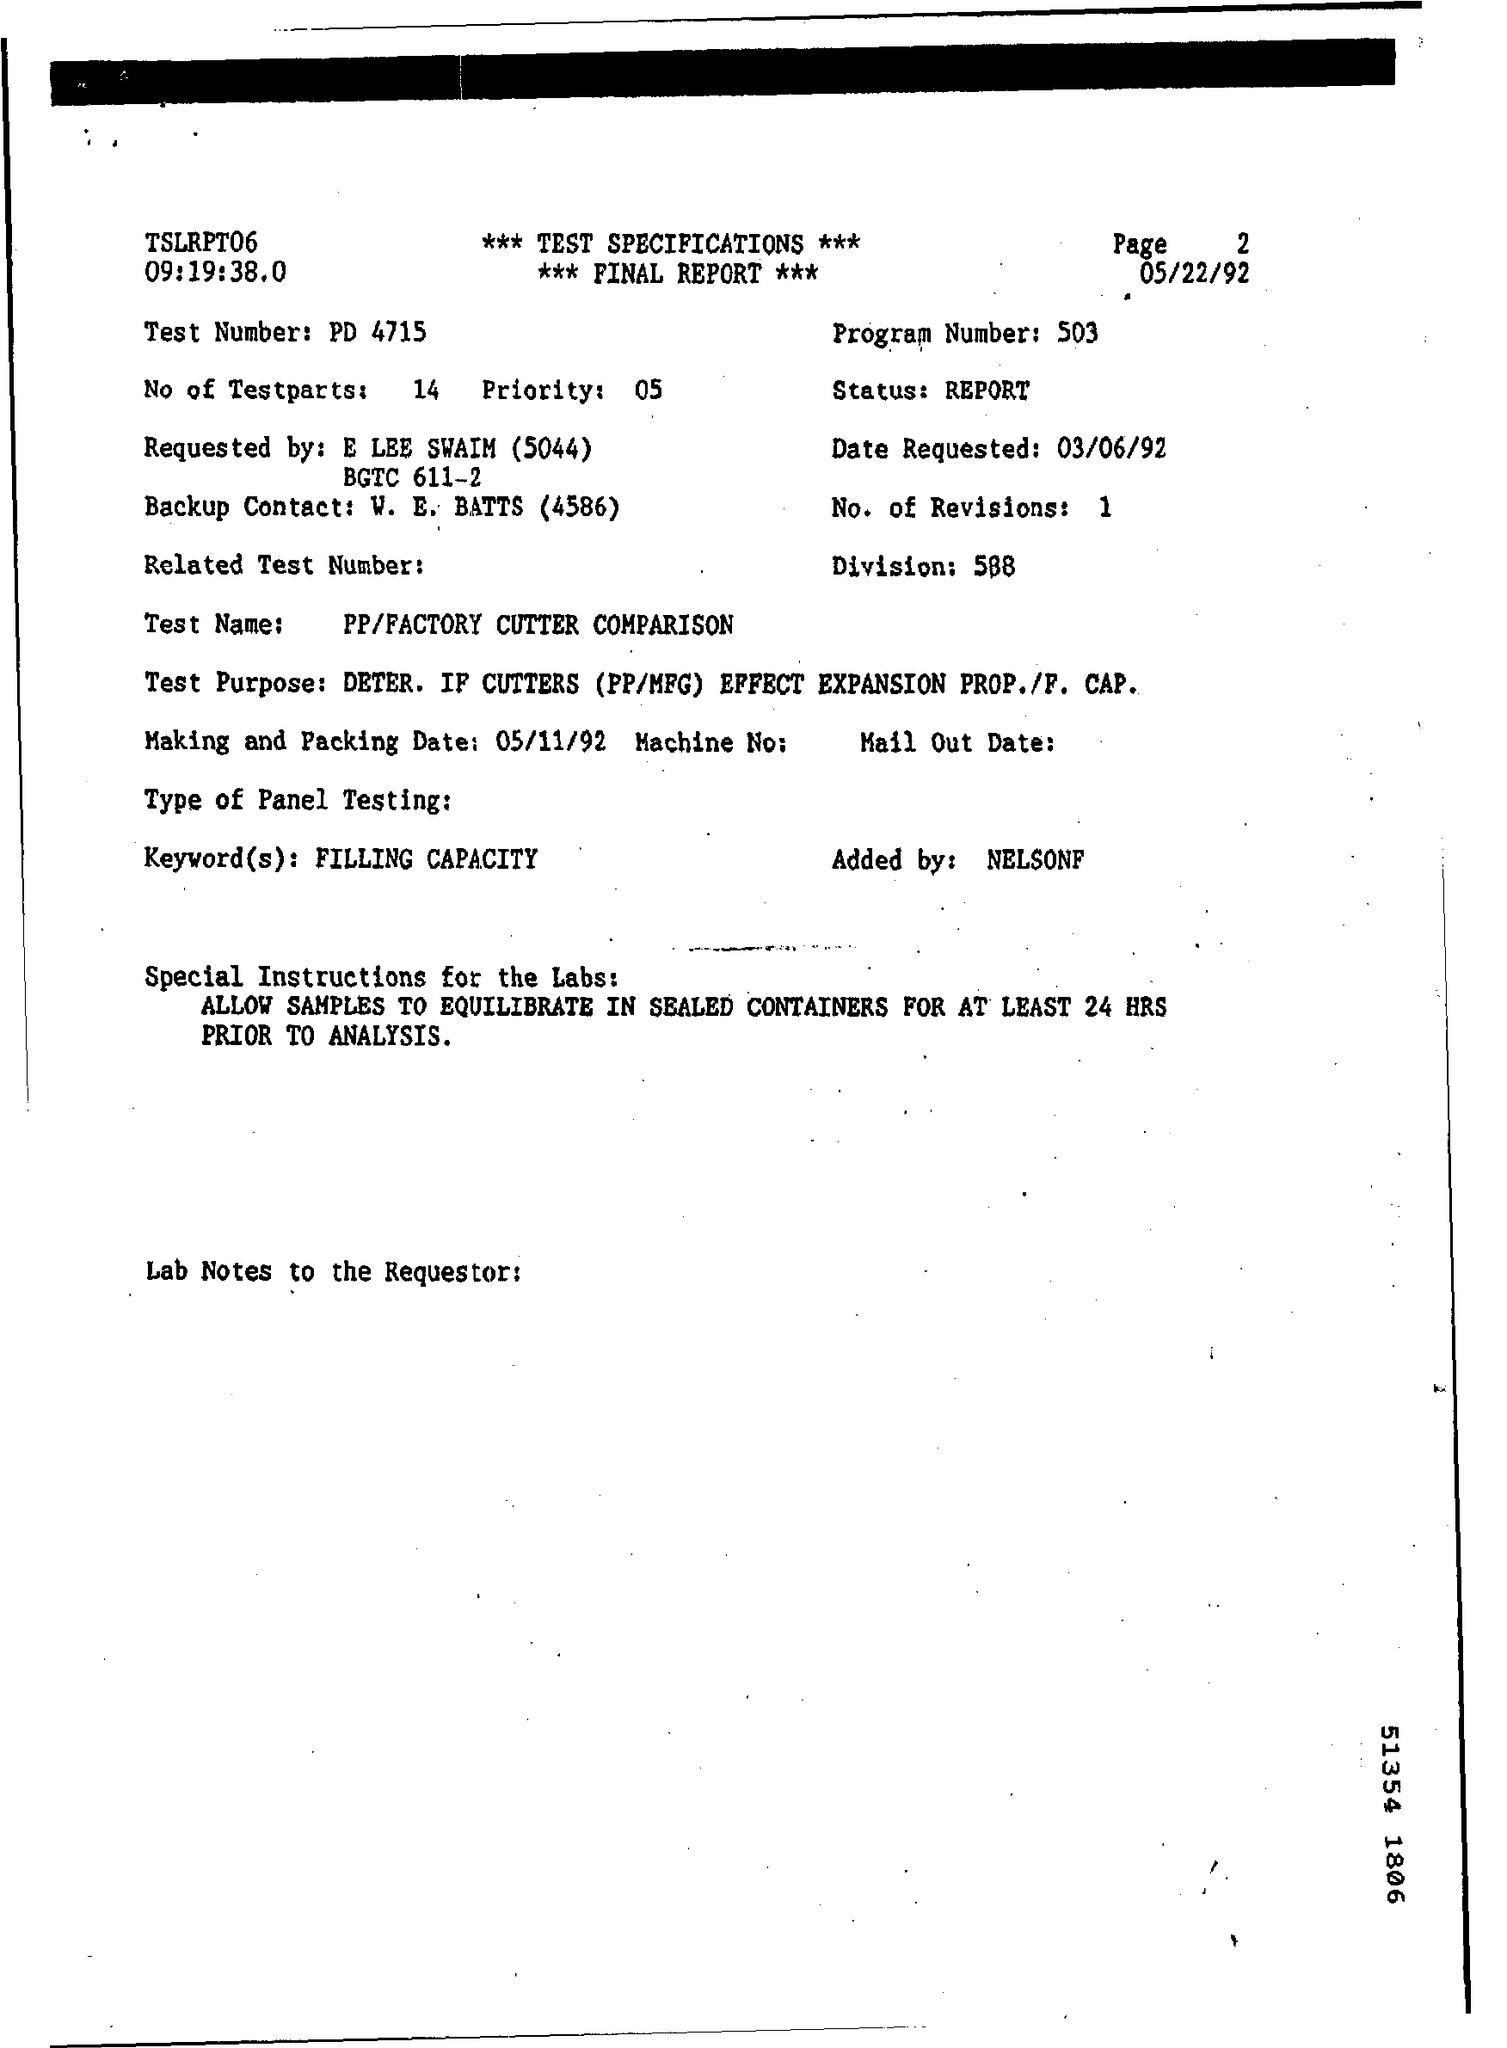What is the page number mentioned ?
Offer a very short reply. 2. What is the program number ?
Make the answer very short. 503. What is the test number?
Your response must be concise. PD 4715. When is the date requested ?
Make the answer very short. 03/06/92. What is the division number or division ?
Offer a very short reply. 588. How many no .of revisions ?
Keep it short and to the point. 1. This is requested by whom ?
Your answer should be very brief. E LEE SWAIM (5044). What is the making and packing date ?
Your answer should be compact. 05/11/92. 